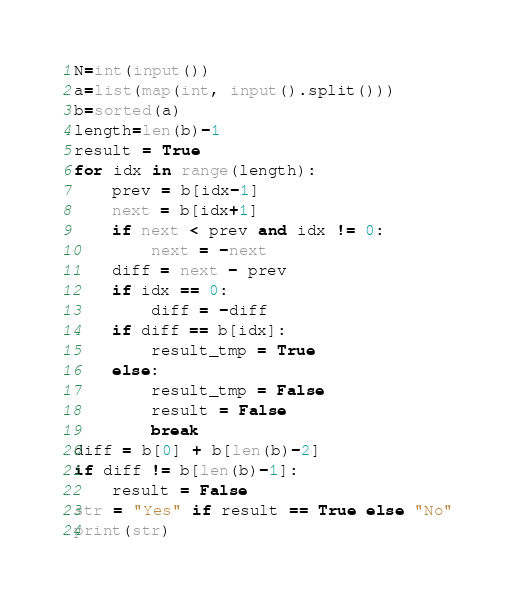<code> <loc_0><loc_0><loc_500><loc_500><_Python_>N=int(input())
a=list(map(int, input().split()))
b=sorted(a)
length=len(b)-1
result = True
for idx in range(length):
    prev = b[idx-1]
    next = b[idx+1]
    if next < prev and idx != 0:
        next = -next
    diff = next - prev
    if idx == 0:
        diff = -diff
    if diff == b[idx]:
        result_tmp = True
    else:
        result_tmp = False
        result = False
        break
diff = b[0] + b[len(b)-2]
if diff != b[len(b)-1]:
    result = False
str = "Yes" if result == True else "No"
print(str)</code> 